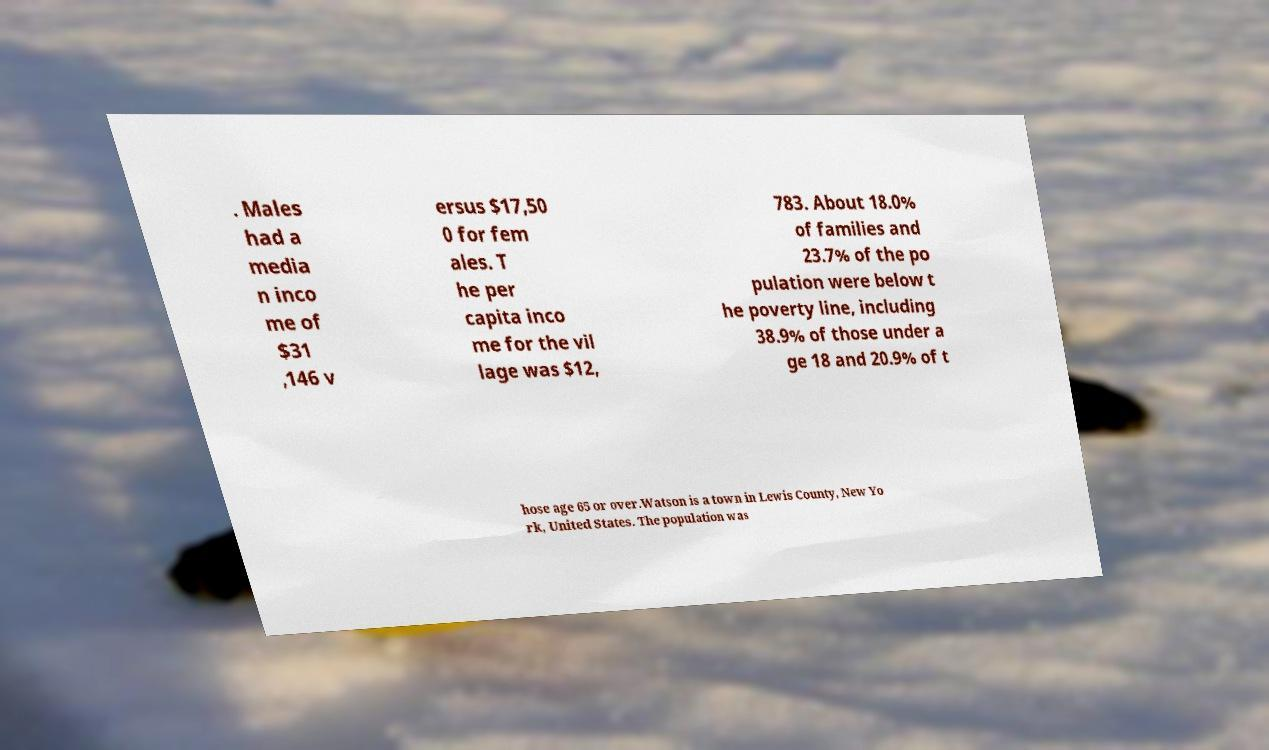What messages or text are displayed in this image? I need them in a readable, typed format. . Males had a media n inco me of $31 ,146 v ersus $17,50 0 for fem ales. T he per capita inco me for the vil lage was $12, 783. About 18.0% of families and 23.7% of the po pulation were below t he poverty line, including 38.9% of those under a ge 18 and 20.9% of t hose age 65 or over.Watson is a town in Lewis County, New Yo rk, United States. The population was 